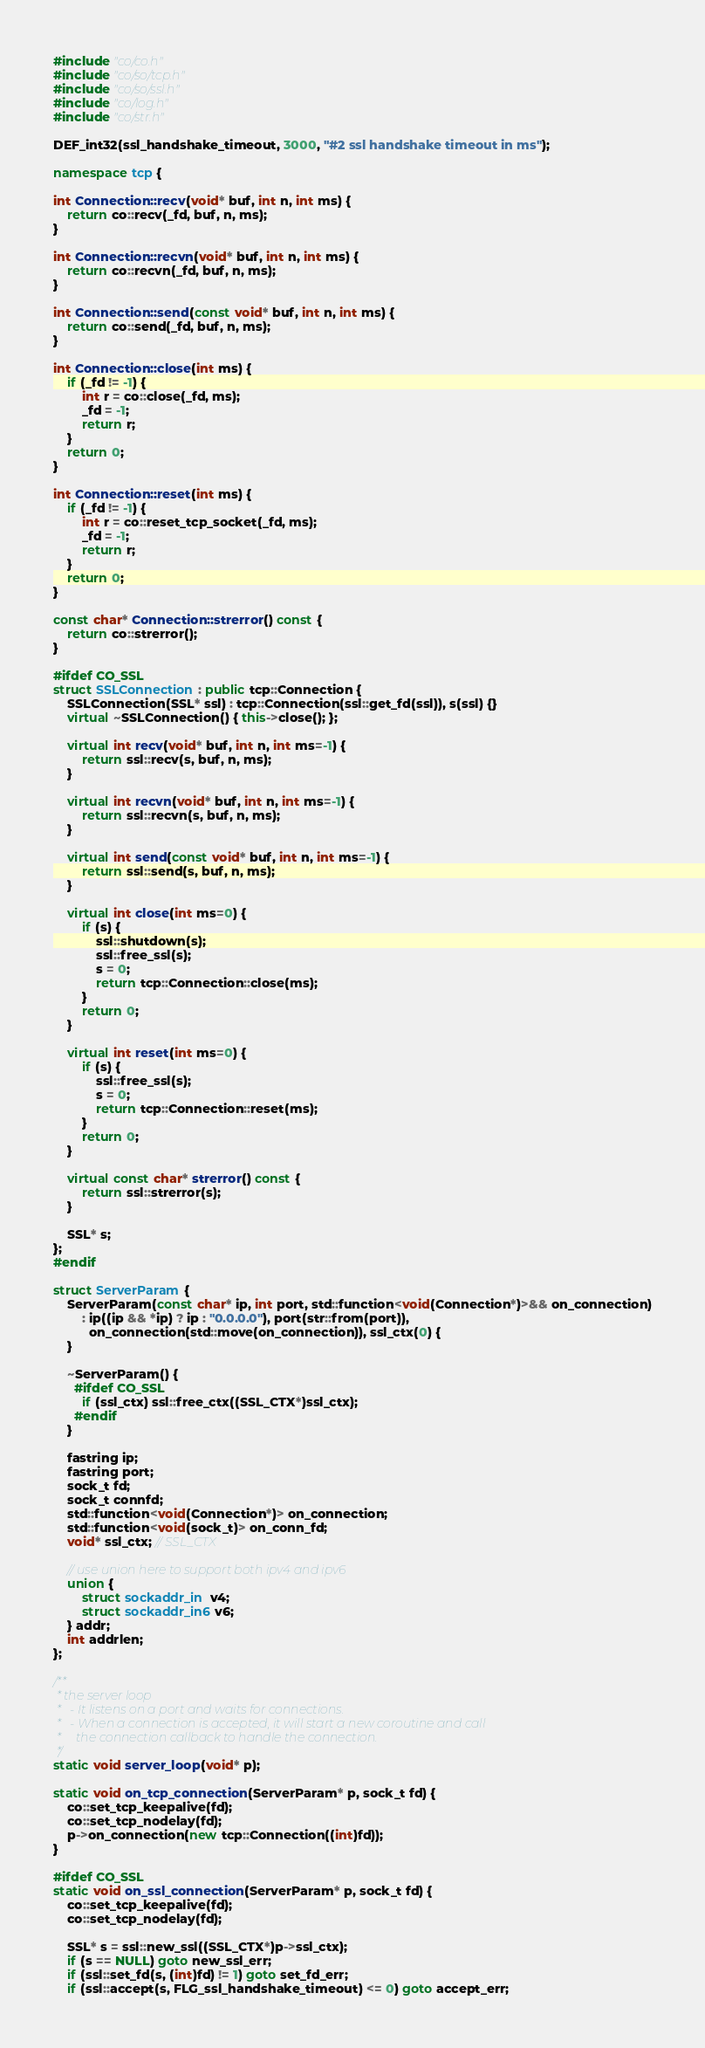Convert code to text. <code><loc_0><loc_0><loc_500><loc_500><_C++_>#include "co/co.h"
#include "co/so/tcp.h"
#include "co/so/ssl.h"
#include "co/log.h"
#include "co/str.h"

DEF_int32(ssl_handshake_timeout, 3000, "#2 ssl handshake timeout in ms");

namespace tcp {

int Connection::recv(void* buf, int n, int ms) {
    return co::recv(_fd, buf, n, ms);
}

int Connection::recvn(void* buf, int n, int ms) {
    return co::recvn(_fd, buf, n, ms);
}

int Connection::send(const void* buf, int n, int ms) {
    return co::send(_fd, buf, n, ms);
}

int Connection::close(int ms) {
    if (_fd != -1) {
        int r = co::close(_fd, ms);
        _fd = -1;
        return r;
    }
    return 0;
}

int Connection::reset(int ms) {
    if (_fd != -1) {
        int r = co::reset_tcp_socket(_fd, ms);
        _fd = -1;
        return r;
    }
    return 0;
}

const char* Connection::strerror() const {
    return co::strerror();
}

#ifdef CO_SSL
struct SSLConnection : public tcp::Connection {
    SSLConnection(SSL* ssl) : tcp::Connection(ssl::get_fd(ssl)), s(ssl) {}
    virtual ~SSLConnection() { this->close(); };

    virtual int recv(void* buf, int n, int ms=-1) {
        return ssl::recv(s, buf, n, ms);
    }

    virtual int recvn(void* buf, int n, int ms=-1) {
        return ssl::recvn(s, buf, n, ms);
    }

    virtual int send(const void* buf, int n, int ms=-1) {
        return ssl::send(s, buf, n, ms);
    }

    virtual int close(int ms=0) {
        if (s) {
            ssl::shutdown(s);
            ssl::free_ssl(s);
            s = 0;
            return tcp::Connection::close(ms);
        }
        return 0;
    }

    virtual int reset(int ms=0) {
        if (s) {
            ssl::free_ssl(s);
            s = 0;
            return tcp::Connection::reset(ms);
        }
        return 0;
    }

    virtual const char* strerror() const {
        return ssl::strerror(s);
    }

    SSL* s;
};
#endif

struct ServerParam {
    ServerParam(const char* ip, int port, std::function<void(Connection*)>&& on_connection)
        : ip((ip && *ip) ? ip : "0.0.0.0"), port(str::from(port)), 
          on_connection(std::move(on_connection)), ssl_ctx(0) {
    }

    ~ServerParam() {
      #ifdef CO_SSL
        if (ssl_ctx) ssl::free_ctx((SSL_CTX*)ssl_ctx);
      #endif
    }

    fastring ip;
    fastring port;
    sock_t fd;
    sock_t connfd;
    std::function<void(Connection*)> on_connection;
    std::function<void(sock_t)> on_conn_fd;
    void* ssl_ctx; // SSL_CTX

    // use union here to support both ipv4 and ipv6
    union {
        struct sockaddr_in  v4;
        struct sockaddr_in6 v6;
    } addr;
    int addrlen;
};

/**
 * the server loop 
 *   - It listens on a port and waits for connections. 
 *   - When a connection is accepted, it will start a new coroutine and call 
 *     the connection callback to handle the connection. 
 */
static void server_loop(void* p);

static void on_tcp_connection(ServerParam* p, sock_t fd) {
    co::set_tcp_keepalive(fd);
    co::set_tcp_nodelay(fd);
    p->on_connection(new tcp::Connection((int)fd));
}

#ifdef CO_SSL
static void on_ssl_connection(ServerParam* p, sock_t fd) {
    co::set_tcp_keepalive(fd);
    co::set_tcp_nodelay(fd);

    SSL* s = ssl::new_ssl((SSL_CTX*)p->ssl_ctx);
    if (s == NULL) goto new_ssl_err;
    if (ssl::set_fd(s, (int)fd) != 1) goto set_fd_err;
    if (ssl::accept(s, FLG_ssl_handshake_timeout) <= 0) goto accept_err;
</code> 